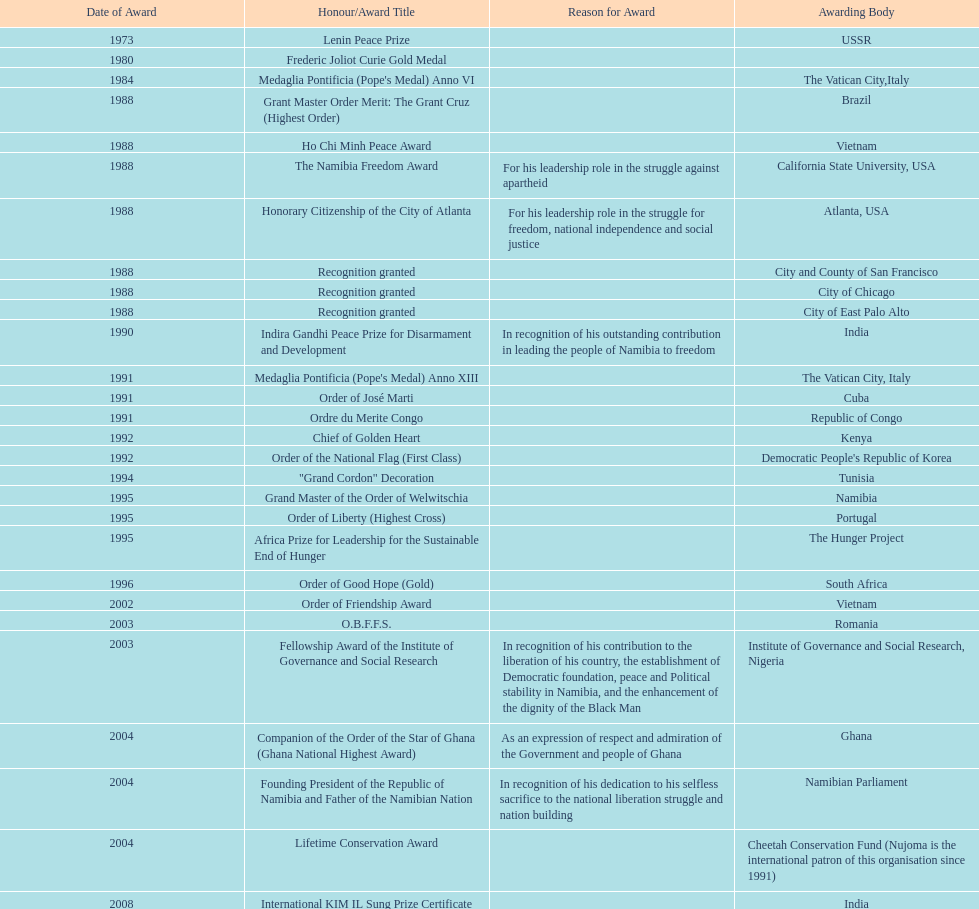What is the total number of awards that nujoma won? 29. 